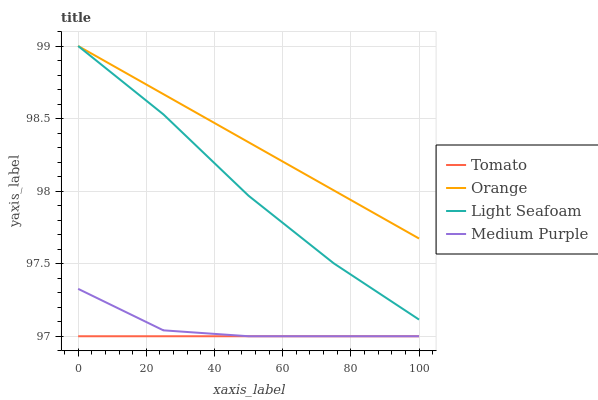Does Medium Purple have the minimum area under the curve?
Answer yes or no. No. Does Medium Purple have the maximum area under the curve?
Answer yes or no. No. Is Orange the smoothest?
Answer yes or no. No. Is Orange the roughest?
Answer yes or no. No. Does Orange have the lowest value?
Answer yes or no. No. Does Medium Purple have the highest value?
Answer yes or no. No. Is Medium Purple less than Light Seafoam?
Answer yes or no. Yes. Is Light Seafoam greater than Tomato?
Answer yes or no. Yes. Does Medium Purple intersect Light Seafoam?
Answer yes or no. No. 